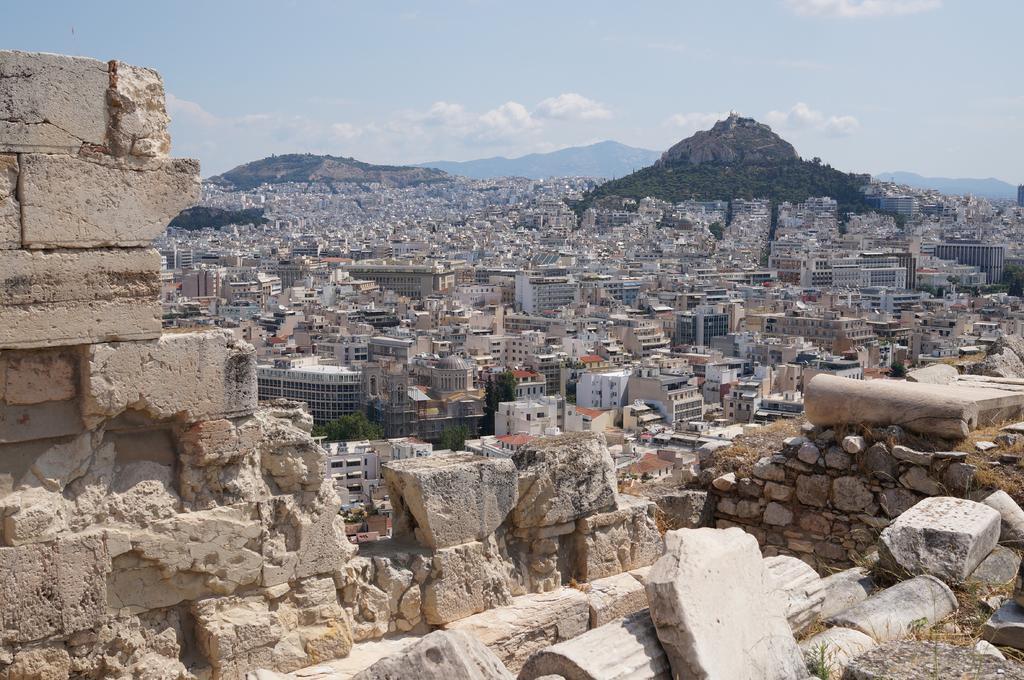Describe this image in one or two sentences. In this picture I can see rocks, there are buildings, trees, there are hills, and in the background there is the sky. 